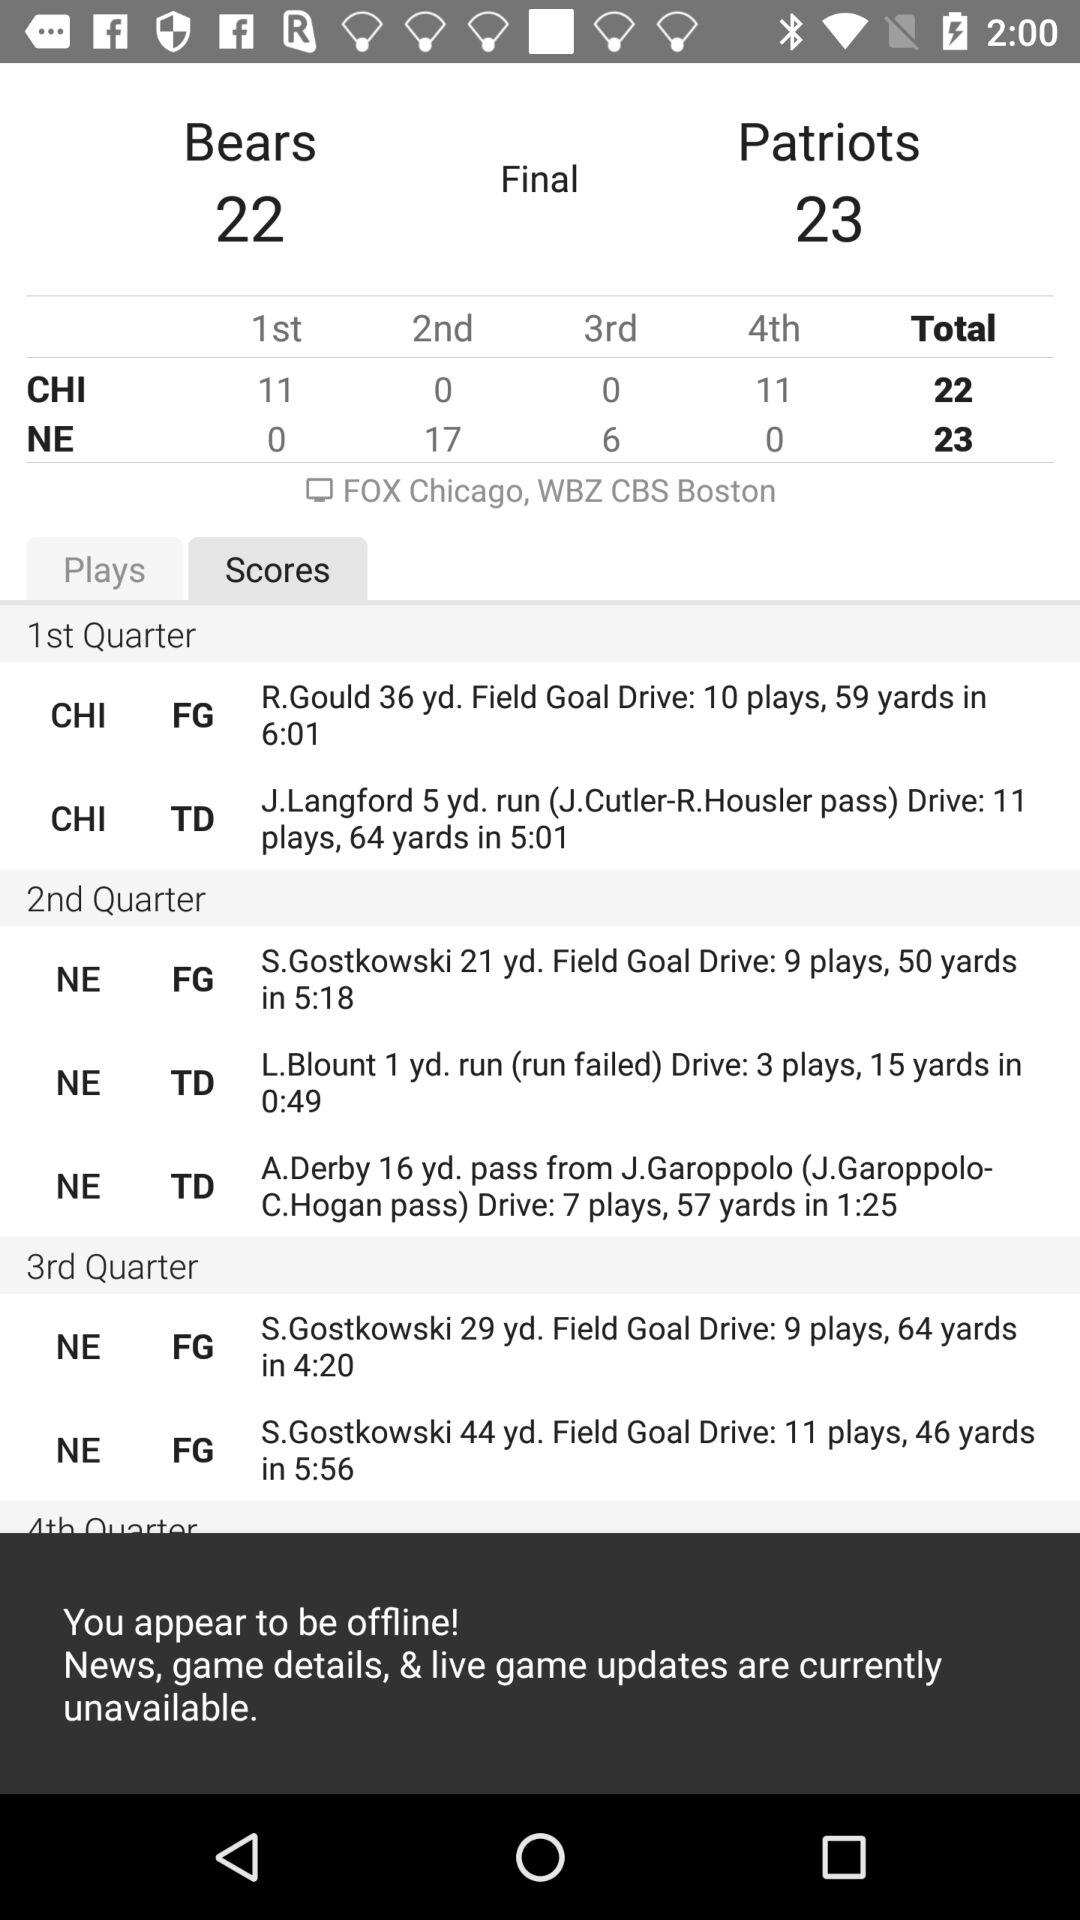What is the total score of NE? The total score of NE is 23. 